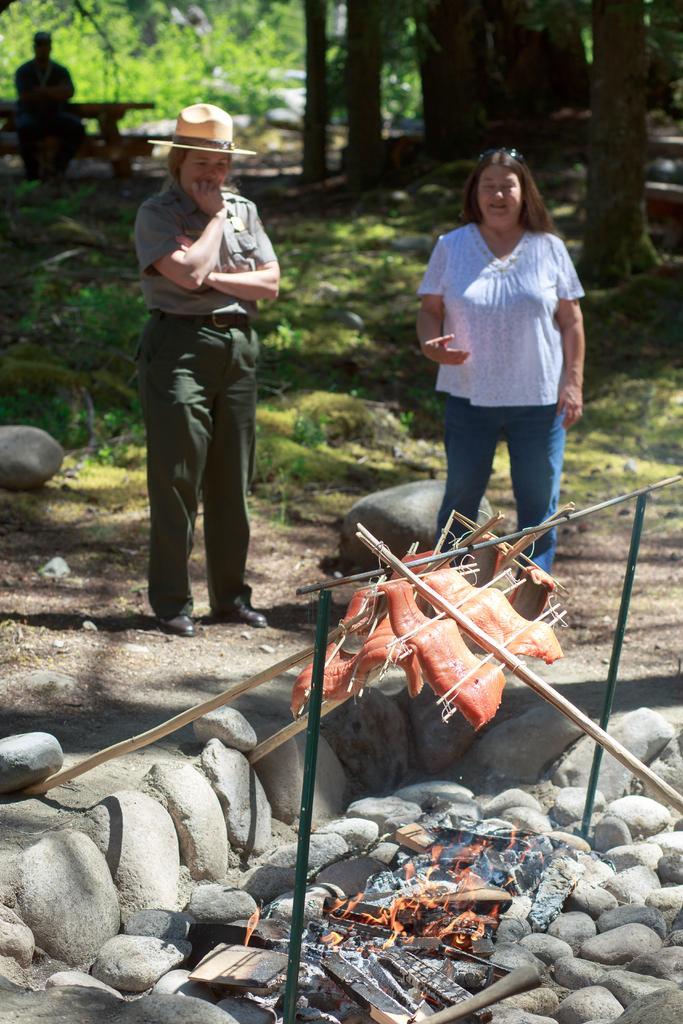Can you describe this image briefly? In the image we can see there are two people standing and one is sitting, they are wearing clothes and the left side person is wearing shoes and a hat. Here we can see stones, flame and meat. Here we can see the grass and the background is slightly blurred. 